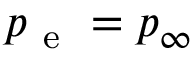<formula> <loc_0><loc_0><loc_500><loc_500>p _ { e } = p _ { \infty }</formula> 